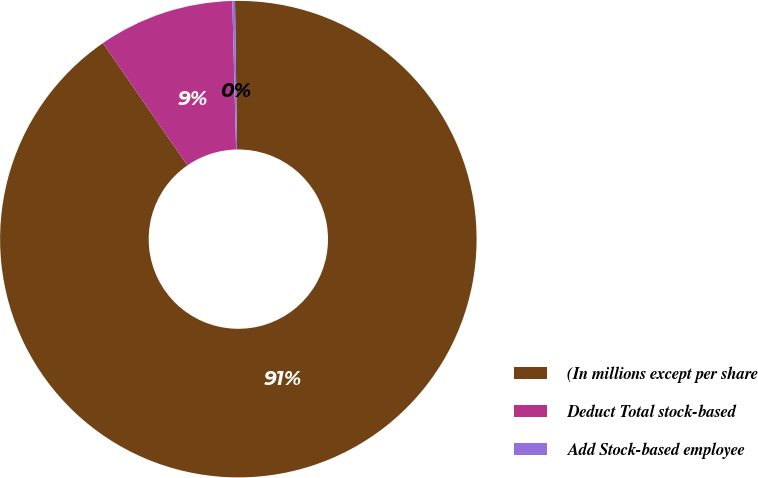<chart> <loc_0><loc_0><loc_500><loc_500><pie_chart><fcel>(In millions except per share<fcel>Deduct Total stock-based<fcel>Add Stock-based employee<nl><fcel>90.6%<fcel>9.22%<fcel>0.18%<nl></chart> 